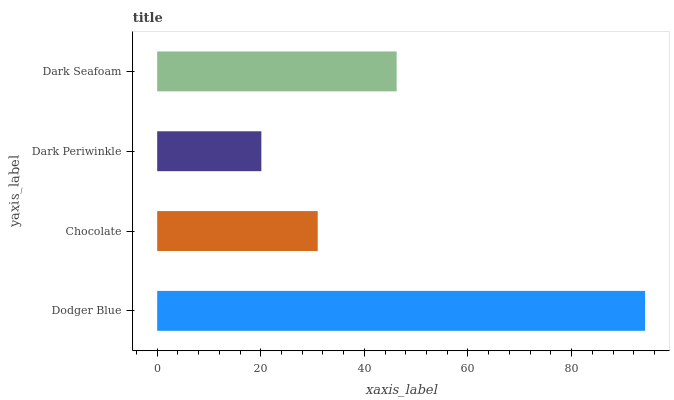Is Dark Periwinkle the minimum?
Answer yes or no. Yes. Is Dodger Blue the maximum?
Answer yes or no. Yes. Is Chocolate the minimum?
Answer yes or no. No. Is Chocolate the maximum?
Answer yes or no. No. Is Dodger Blue greater than Chocolate?
Answer yes or no. Yes. Is Chocolate less than Dodger Blue?
Answer yes or no. Yes. Is Chocolate greater than Dodger Blue?
Answer yes or no. No. Is Dodger Blue less than Chocolate?
Answer yes or no. No. Is Dark Seafoam the high median?
Answer yes or no. Yes. Is Chocolate the low median?
Answer yes or no. Yes. Is Chocolate the high median?
Answer yes or no. No. Is Dark Periwinkle the low median?
Answer yes or no. No. 